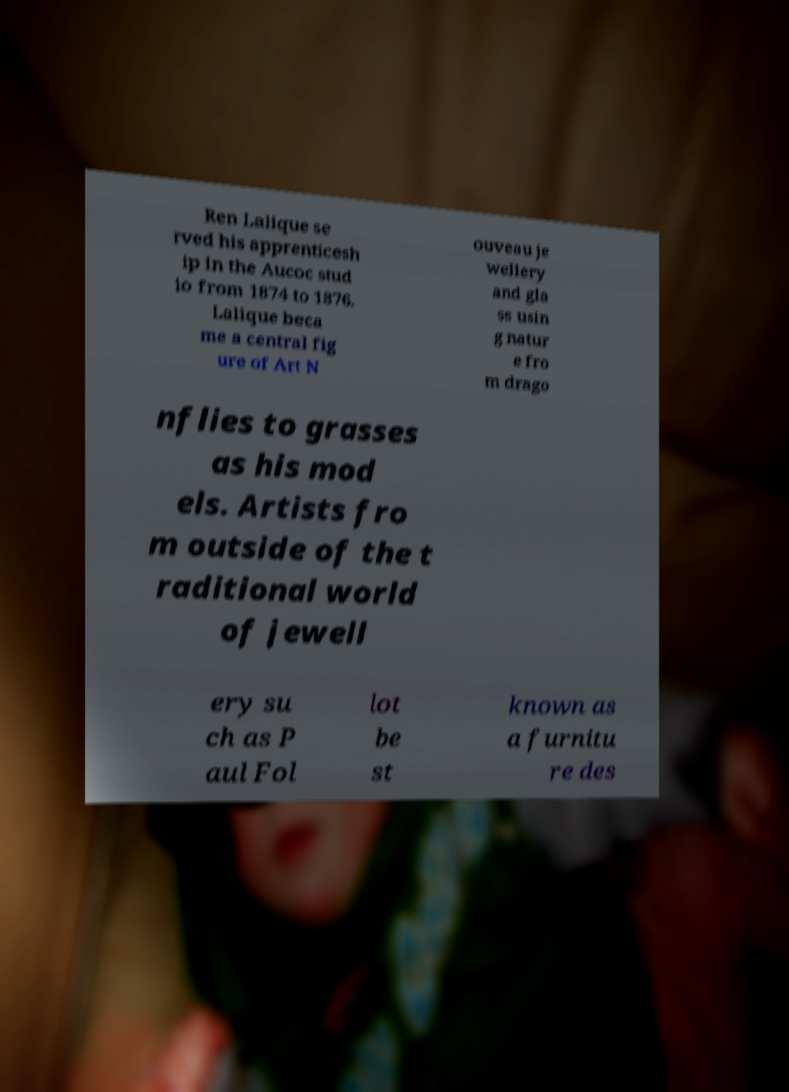Can you read and provide the text displayed in the image?This photo seems to have some interesting text. Can you extract and type it out for me? Ren Lalique se rved his apprenticesh ip in the Aucoc stud io from 1874 to 1876. Lalique beca me a central fig ure of Art N ouveau je wellery and gla ss usin g natur e fro m drago nflies to grasses as his mod els. Artists fro m outside of the t raditional world of jewell ery su ch as P aul Fol lot be st known as a furnitu re des 